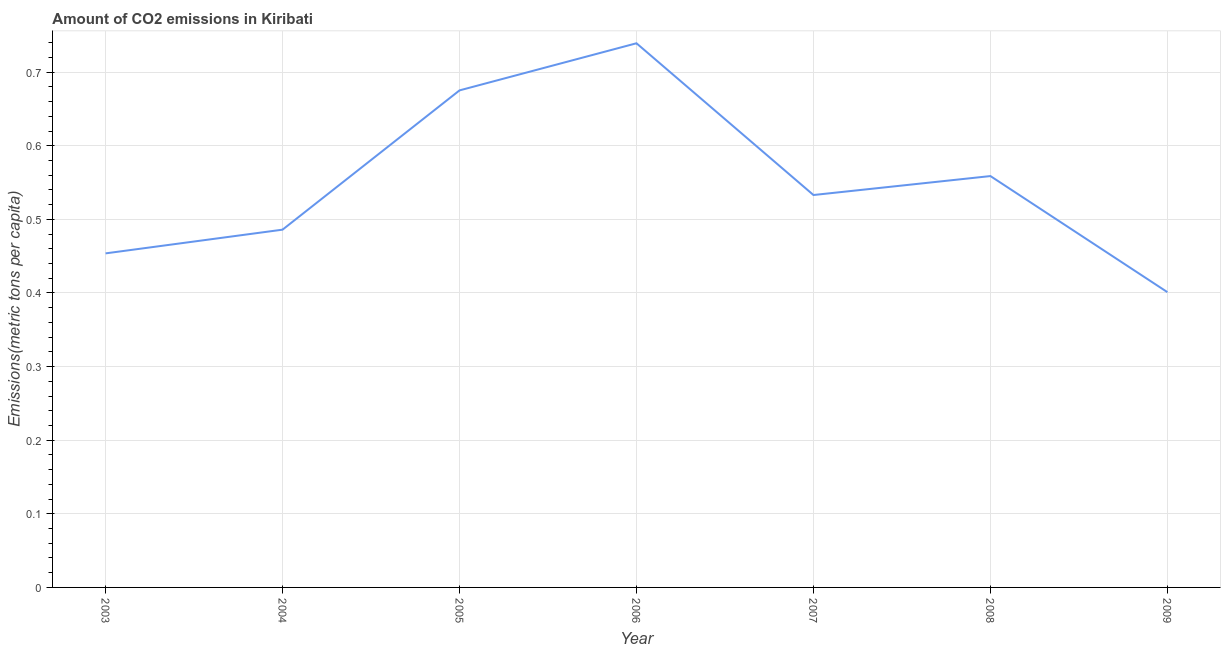What is the amount of co2 emissions in 2005?
Your response must be concise. 0.68. Across all years, what is the maximum amount of co2 emissions?
Keep it short and to the point. 0.74. Across all years, what is the minimum amount of co2 emissions?
Your response must be concise. 0.4. In which year was the amount of co2 emissions minimum?
Make the answer very short. 2009. What is the sum of the amount of co2 emissions?
Provide a succinct answer. 3.85. What is the difference between the amount of co2 emissions in 2006 and 2009?
Ensure brevity in your answer.  0.34. What is the average amount of co2 emissions per year?
Provide a short and direct response. 0.55. What is the median amount of co2 emissions?
Provide a short and direct response. 0.53. Do a majority of the years between 2009 and 2006 (inclusive) have amount of co2 emissions greater than 0.6600000000000001 metric tons per capita?
Offer a terse response. Yes. What is the ratio of the amount of co2 emissions in 2005 to that in 2006?
Your answer should be compact. 0.91. Is the difference between the amount of co2 emissions in 2004 and 2009 greater than the difference between any two years?
Your answer should be compact. No. What is the difference between the highest and the second highest amount of co2 emissions?
Give a very brief answer. 0.06. What is the difference between the highest and the lowest amount of co2 emissions?
Your answer should be compact. 0.34. Does the amount of co2 emissions monotonically increase over the years?
Make the answer very short. No. How many lines are there?
Your answer should be compact. 1. How many years are there in the graph?
Offer a terse response. 7. What is the difference between two consecutive major ticks on the Y-axis?
Provide a succinct answer. 0.1. Does the graph contain grids?
Your response must be concise. Yes. What is the title of the graph?
Keep it short and to the point. Amount of CO2 emissions in Kiribati. What is the label or title of the Y-axis?
Offer a very short reply. Emissions(metric tons per capita). What is the Emissions(metric tons per capita) of 2003?
Ensure brevity in your answer.  0.45. What is the Emissions(metric tons per capita) in 2004?
Offer a terse response. 0.49. What is the Emissions(metric tons per capita) in 2005?
Ensure brevity in your answer.  0.68. What is the Emissions(metric tons per capita) in 2006?
Ensure brevity in your answer.  0.74. What is the Emissions(metric tons per capita) in 2007?
Provide a succinct answer. 0.53. What is the Emissions(metric tons per capita) in 2008?
Offer a terse response. 0.56. What is the Emissions(metric tons per capita) of 2009?
Provide a short and direct response. 0.4. What is the difference between the Emissions(metric tons per capita) in 2003 and 2004?
Give a very brief answer. -0.03. What is the difference between the Emissions(metric tons per capita) in 2003 and 2005?
Make the answer very short. -0.22. What is the difference between the Emissions(metric tons per capita) in 2003 and 2006?
Offer a terse response. -0.29. What is the difference between the Emissions(metric tons per capita) in 2003 and 2007?
Your answer should be very brief. -0.08. What is the difference between the Emissions(metric tons per capita) in 2003 and 2008?
Your answer should be compact. -0.11. What is the difference between the Emissions(metric tons per capita) in 2003 and 2009?
Your response must be concise. 0.05. What is the difference between the Emissions(metric tons per capita) in 2004 and 2005?
Provide a succinct answer. -0.19. What is the difference between the Emissions(metric tons per capita) in 2004 and 2006?
Offer a very short reply. -0.25. What is the difference between the Emissions(metric tons per capita) in 2004 and 2007?
Provide a succinct answer. -0.05. What is the difference between the Emissions(metric tons per capita) in 2004 and 2008?
Provide a short and direct response. -0.07. What is the difference between the Emissions(metric tons per capita) in 2004 and 2009?
Offer a very short reply. 0.08. What is the difference between the Emissions(metric tons per capita) in 2005 and 2006?
Keep it short and to the point. -0.06. What is the difference between the Emissions(metric tons per capita) in 2005 and 2007?
Your answer should be very brief. 0.14. What is the difference between the Emissions(metric tons per capita) in 2005 and 2008?
Provide a succinct answer. 0.12. What is the difference between the Emissions(metric tons per capita) in 2005 and 2009?
Provide a succinct answer. 0.27. What is the difference between the Emissions(metric tons per capita) in 2006 and 2007?
Provide a succinct answer. 0.21. What is the difference between the Emissions(metric tons per capita) in 2006 and 2008?
Make the answer very short. 0.18. What is the difference between the Emissions(metric tons per capita) in 2006 and 2009?
Give a very brief answer. 0.34. What is the difference between the Emissions(metric tons per capita) in 2007 and 2008?
Your response must be concise. -0.03. What is the difference between the Emissions(metric tons per capita) in 2007 and 2009?
Your response must be concise. 0.13. What is the difference between the Emissions(metric tons per capita) in 2008 and 2009?
Your answer should be very brief. 0.16. What is the ratio of the Emissions(metric tons per capita) in 2003 to that in 2004?
Offer a very short reply. 0.93. What is the ratio of the Emissions(metric tons per capita) in 2003 to that in 2005?
Your answer should be compact. 0.67. What is the ratio of the Emissions(metric tons per capita) in 2003 to that in 2006?
Provide a short and direct response. 0.61. What is the ratio of the Emissions(metric tons per capita) in 2003 to that in 2007?
Ensure brevity in your answer.  0.85. What is the ratio of the Emissions(metric tons per capita) in 2003 to that in 2008?
Provide a succinct answer. 0.81. What is the ratio of the Emissions(metric tons per capita) in 2003 to that in 2009?
Give a very brief answer. 1.13. What is the ratio of the Emissions(metric tons per capita) in 2004 to that in 2005?
Your answer should be compact. 0.72. What is the ratio of the Emissions(metric tons per capita) in 2004 to that in 2006?
Your answer should be compact. 0.66. What is the ratio of the Emissions(metric tons per capita) in 2004 to that in 2007?
Give a very brief answer. 0.91. What is the ratio of the Emissions(metric tons per capita) in 2004 to that in 2008?
Give a very brief answer. 0.87. What is the ratio of the Emissions(metric tons per capita) in 2004 to that in 2009?
Ensure brevity in your answer.  1.21. What is the ratio of the Emissions(metric tons per capita) in 2005 to that in 2007?
Offer a terse response. 1.27. What is the ratio of the Emissions(metric tons per capita) in 2005 to that in 2008?
Your answer should be very brief. 1.21. What is the ratio of the Emissions(metric tons per capita) in 2005 to that in 2009?
Keep it short and to the point. 1.68. What is the ratio of the Emissions(metric tons per capita) in 2006 to that in 2007?
Your answer should be compact. 1.39. What is the ratio of the Emissions(metric tons per capita) in 2006 to that in 2008?
Give a very brief answer. 1.32. What is the ratio of the Emissions(metric tons per capita) in 2006 to that in 2009?
Offer a very short reply. 1.84. What is the ratio of the Emissions(metric tons per capita) in 2007 to that in 2008?
Offer a terse response. 0.95. What is the ratio of the Emissions(metric tons per capita) in 2007 to that in 2009?
Offer a terse response. 1.33. What is the ratio of the Emissions(metric tons per capita) in 2008 to that in 2009?
Offer a terse response. 1.39. 